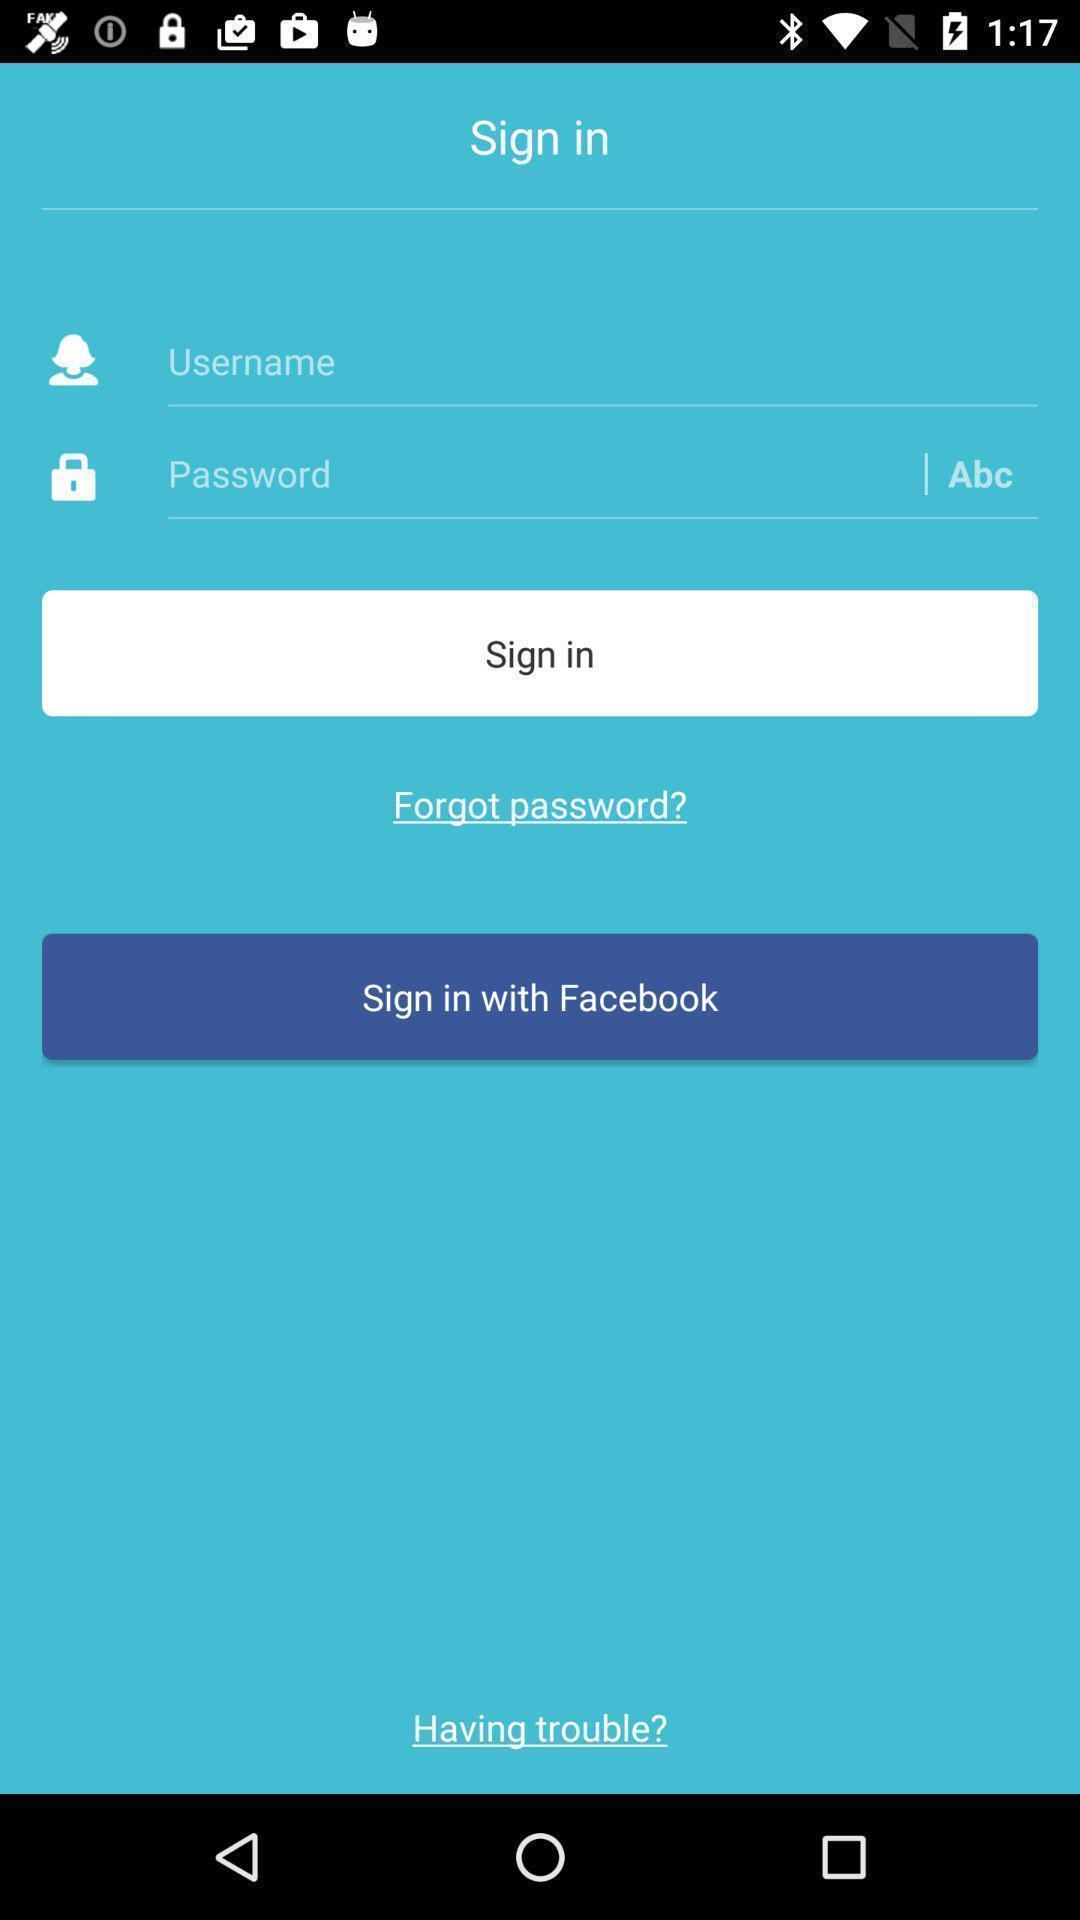Please provide a description for this image. Sign in page of a social application. 